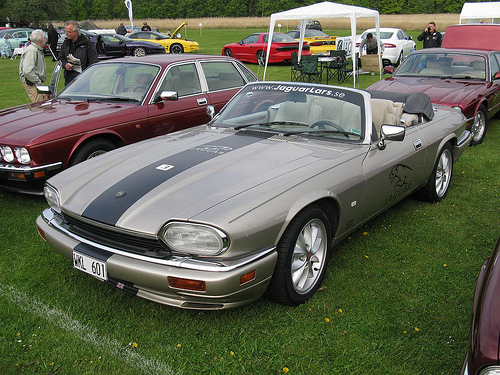<image>
Is the car on the grass? Yes. Looking at the image, I can see the car is positioned on top of the grass, with the grass providing support. 